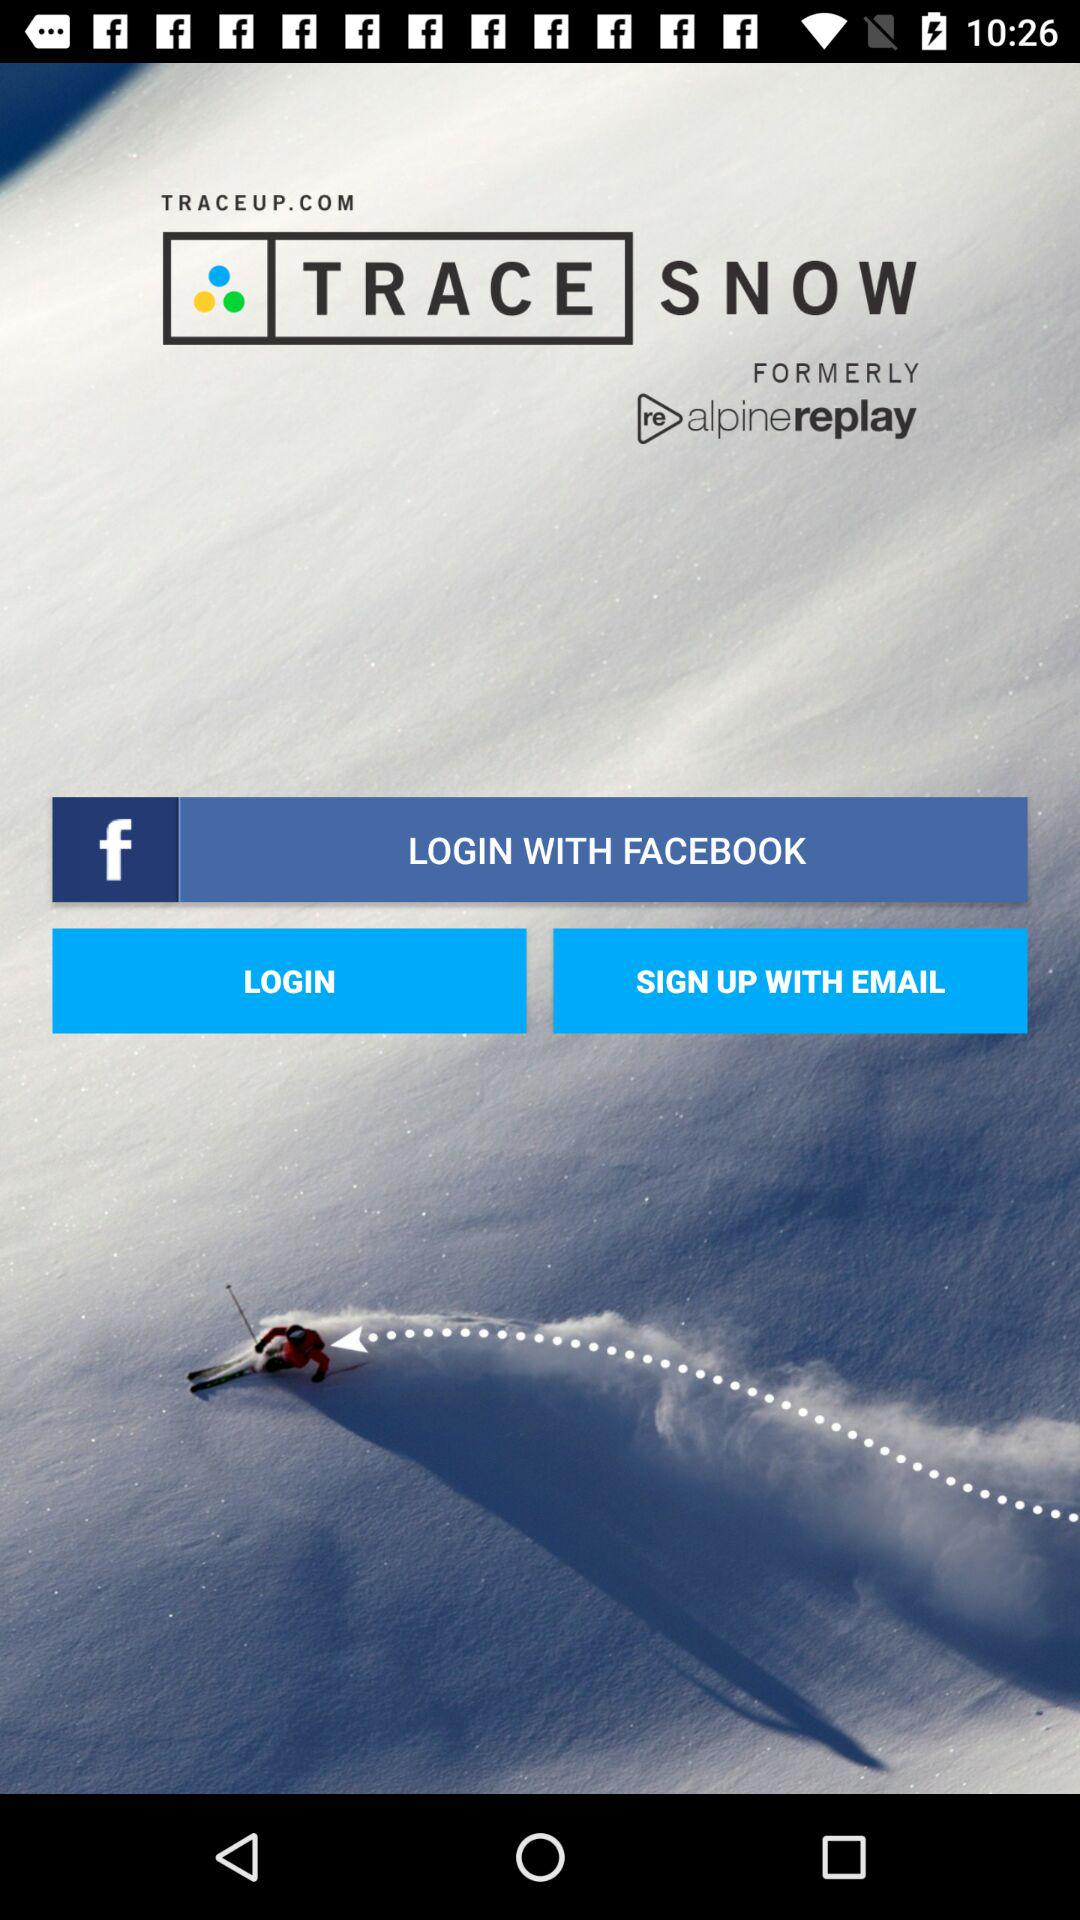Is "Facebook" utilized for logging in?
When the provided information is insufficient, respond with <no answer>. <no answer> 